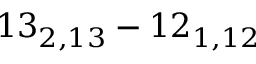<formula> <loc_0><loc_0><loc_500><loc_500>1 3 _ { 2 , 1 3 } - 1 2 _ { 1 , 1 2 }</formula> 